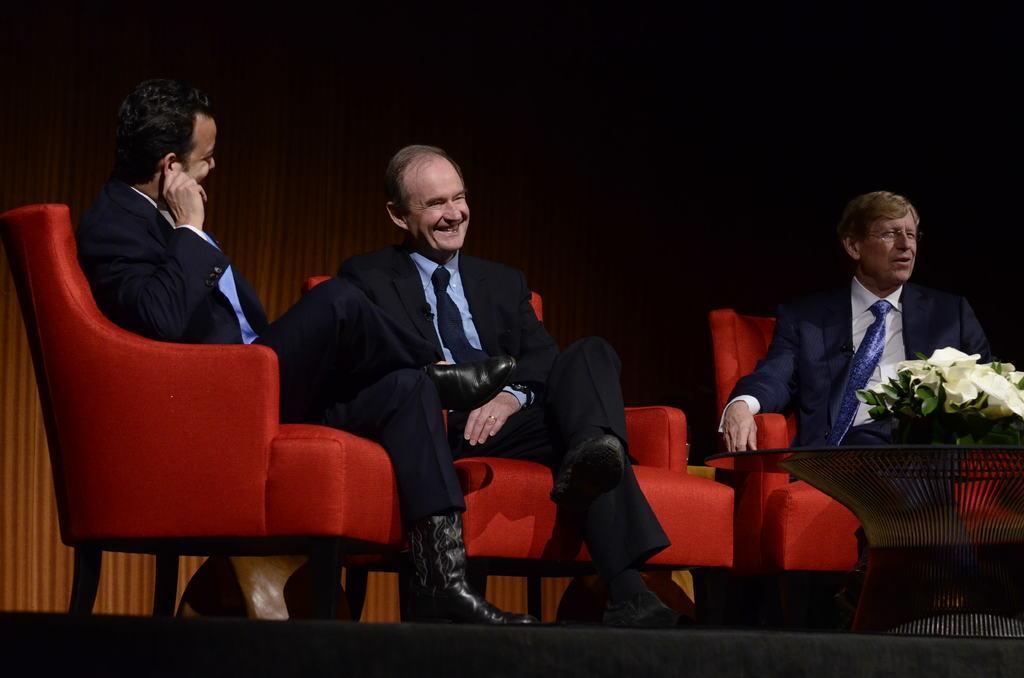Can you describe this image briefly? Here we can see three men sitting on chairs with a table in front of them having a flower pot on it 